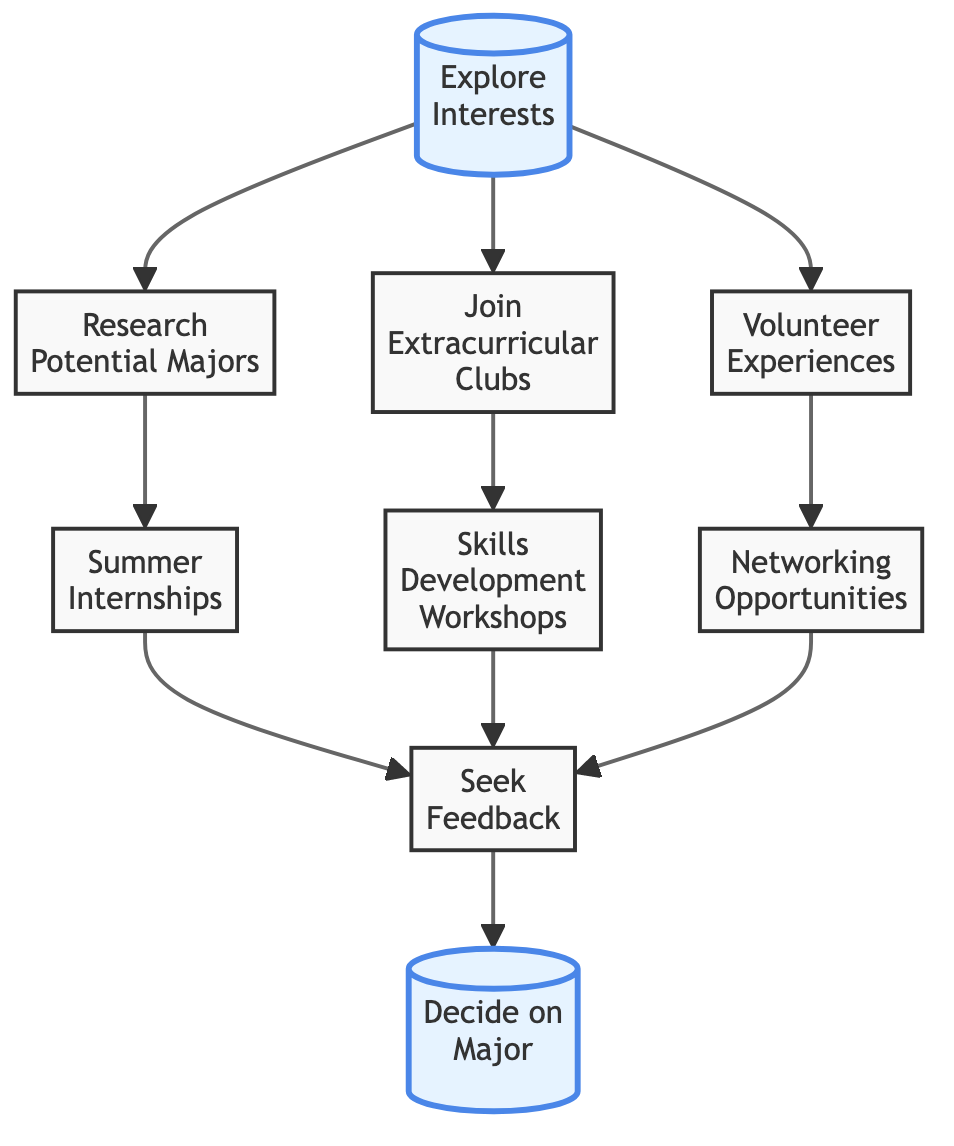What is the starting point of the flowchart? The flowchart begins with the node labeled "Explore Interests," indicating the initial step in the process of exploring extracurricular activities.
Answer: Explore Interests How many nodes are in the diagram? By counting all the individual nodes, we find there are eight distinct nodes present in the flowchart.
Answer: 8 What is the final decision in the flowchart? The final outcome of the flowchart leads to the node labeled "Decide on Major," which signifies the conclusion of the pathway.
Answer: Decide on Major Which activity is linked to "Research Potential Majors"? The node directly connected to "Research Potential Majors" is "Summer Internships," indicating that after researching, the next step involves applying for internships.
Answer: Summer Internships Which two activities are branched from "Join Extracurricular Clubs"? The activities that branch out from "Join Extracurricular Clubs" are "Skills Development Workshops," showing a direct connection to enhancing skills through workshops.
Answer: Skills Development Workshops What type of experiences are associated with "Volunteer Experiences"? The activity linked to "Volunteer Experiences" is "Networking Opportunities," suggesting that volunteering enables connections with professionals.
Answer: Networking Opportunities How many connections lead to "Seek Feedback"? There are three different pathways leading to "Seek Feedback," which includes inputs from "Summer Internships," "Skills Development Workshops," and "Networking Opportunities."
Answer: 3 What is the purpose of the "Skills Development Workshops" node? The purpose of "Skills Development Workshops" is to enhance skills through specific training before seeking feedback on experiences.
Answer: Enhance skills What is the connection between "Internships" and "Feedback"? The connection indicates that after participating in internships, one should seek feedback, highlighting the importance of discussion on the internship experience.
Answer: Seek Feedback 